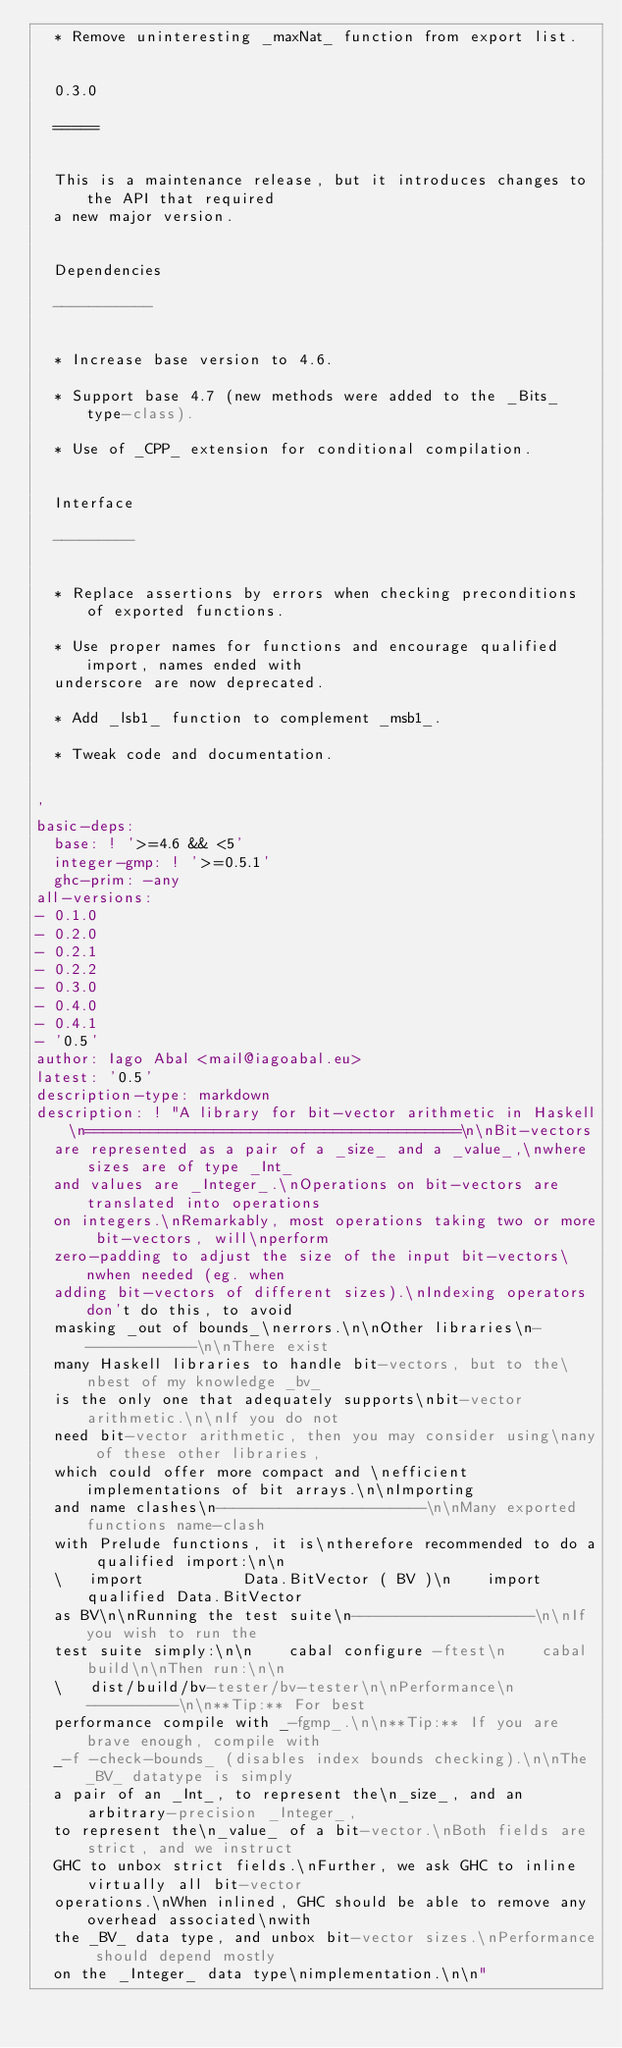Convert code to text. <code><loc_0><loc_0><loc_500><loc_500><_YAML_>  * Remove uninteresting _maxNat_ function from export list.


  0.3.0

  =====


  This is a maintenance release, but it introduces changes to the API that required
  a new major version.


  Dependencies

  -----------


  * Increase base version to 4.6.

  * Support base 4.7 (new methods were added to the _Bits_ type-class).

  * Use of _CPP_ extension for conditional compilation.


  Interface

  ---------


  * Replace assertions by errors when checking preconditions of exported functions.

  * Use proper names for functions and encourage qualified import, names ended with
  underscore are now deprecated.

  * Add _lsb1_ function to complement _msb1_.

  * Tweak code and documentation.


'
basic-deps:
  base: ! '>=4.6 && <5'
  integer-gmp: ! '>=0.5.1'
  ghc-prim: -any
all-versions:
- 0.1.0
- 0.2.0
- 0.2.1
- 0.2.2
- 0.3.0
- 0.4.0
- 0.4.1
- '0.5'
author: Iago Abal <mail@iagoabal.eu>
latest: '0.5'
description-type: markdown
description: ! "A library for bit-vector arithmetic in Haskell\n=========================================\n\nBit-vectors
  are represented as a pair of a _size_ and a _value_,\nwhere sizes are of type _Int_
  and values are _Integer_.\nOperations on bit-vectors are translated into operations
  on integers.\nRemarkably, most operations taking two or more bit-vectors, will\nperform
  zero-padding to adjust the size of the input bit-vectors\nwhen needed (eg. when
  adding bit-vectors of different sizes).\nIndexing operators don't do this, to avoid
  masking _out of bounds_\nerrors.\n\nOther libraries\n-------------\n\nThere exist
  many Haskell libraries to handle bit-vectors, but to the\nbest of my knowledge _bv_
  is the only one that adequately supports\nbit-vector arithmetic.\n\nIf you do not
  need bit-vector arithmetic, then you may consider using\nany of these other libraries,
  which could offer more compact and \nefficient implementations of bit arrays.\n\nImporting
  and name clashes\n-----------------------\n\nMany exported functions name-clash
  with Prelude functions, it is\ntherefore recommended to do a qualified import:\n\n
  \   import           Data.BitVector ( BV )\n    import qualified Data.BitVector
  as BV\n\nRunning the test suite\n--------------------\n\nIf you wish to run the
  test suite simply:\n\n    cabal configure -ftest\n    cabal build\n\nThen run:\n\n
  \   dist/build/bv-tester/bv-tester\n\nPerformance\n----------\n\n**Tip:** For best
  performance compile with _-fgmp_.\n\n**Tip:** If you are brave enough, compile with
  _-f -check-bounds_ (disables index bounds checking).\n\nThe _BV_ datatype is simply
  a pair of an _Int_, to represent the\n_size_, and an arbitrary-precision _Integer_,
  to represent the\n_value_ of a bit-vector.\nBoth fields are strict, and we instruct
  GHC to unbox strict fields.\nFurther, we ask GHC to inline virtually all bit-vector
  operations.\nWhen inlined, GHC should be able to remove any overhead associated\nwith
  the _BV_ data type, and unbox bit-vector sizes.\nPerformance should depend mostly
  on the _Integer_ data type\nimplementation.\n\n"</code> 